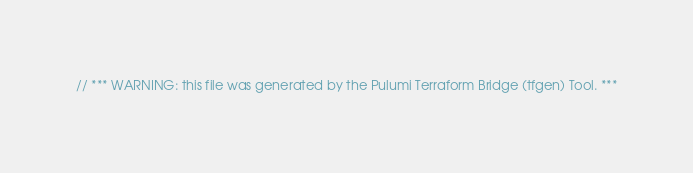Convert code to text. <code><loc_0><loc_0><loc_500><loc_500><_C#_>// *** WARNING: this file was generated by the Pulumi Terraform Bridge (tfgen) Tool. ***</code> 